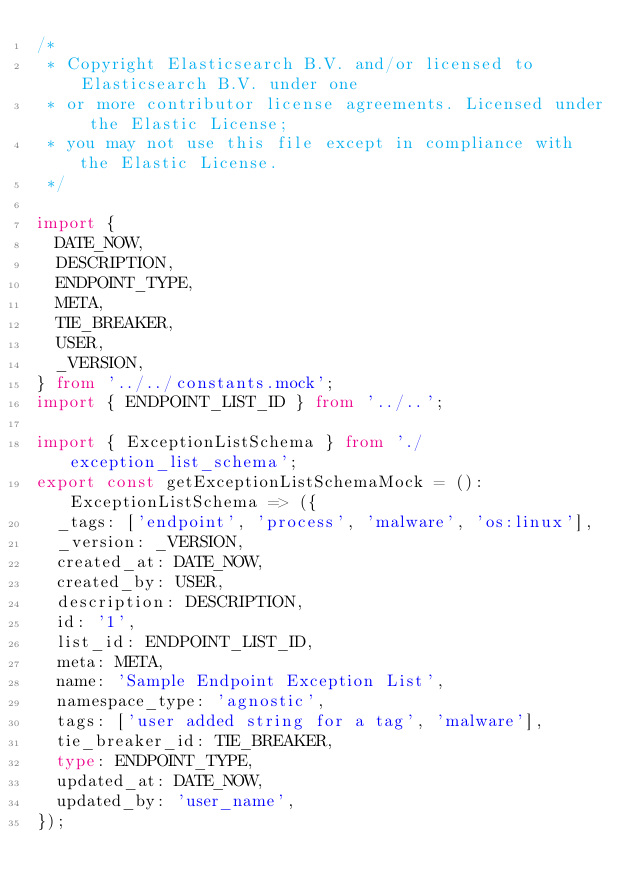<code> <loc_0><loc_0><loc_500><loc_500><_TypeScript_>/*
 * Copyright Elasticsearch B.V. and/or licensed to Elasticsearch B.V. under one
 * or more contributor license agreements. Licensed under the Elastic License;
 * you may not use this file except in compliance with the Elastic License.
 */

import {
  DATE_NOW,
  DESCRIPTION,
  ENDPOINT_TYPE,
  META,
  TIE_BREAKER,
  USER,
  _VERSION,
} from '../../constants.mock';
import { ENDPOINT_LIST_ID } from '../..';

import { ExceptionListSchema } from './exception_list_schema';
export const getExceptionListSchemaMock = (): ExceptionListSchema => ({
  _tags: ['endpoint', 'process', 'malware', 'os:linux'],
  _version: _VERSION,
  created_at: DATE_NOW,
  created_by: USER,
  description: DESCRIPTION,
  id: '1',
  list_id: ENDPOINT_LIST_ID,
  meta: META,
  name: 'Sample Endpoint Exception List',
  namespace_type: 'agnostic',
  tags: ['user added string for a tag', 'malware'],
  tie_breaker_id: TIE_BREAKER,
  type: ENDPOINT_TYPE,
  updated_at: DATE_NOW,
  updated_by: 'user_name',
});
</code> 